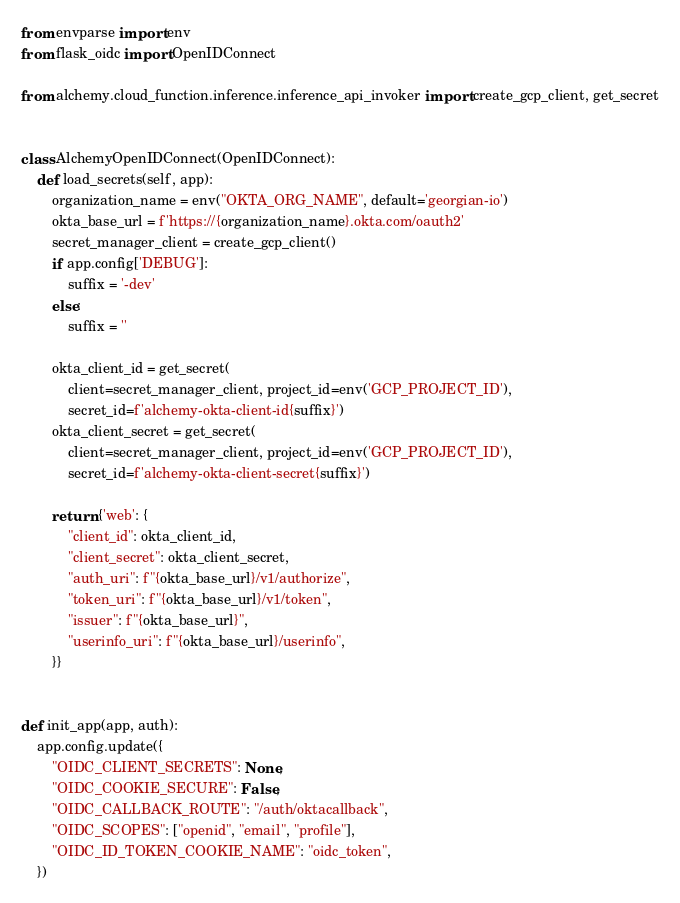Convert code to text. <code><loc_0><loc_0><loc_500><loc_500><_Python_>from envparse import env
from flask_oidc import OpenIDConnect

from alchemy.cloud_function.inference.inference_api_invoker import create_gcp_client, get_secret


class AlchemyOpenIDConnect(OpenIDConnect):
    def load_secrets(self, app):
        organization_name = env("OKTA_ORG_NAME", default='georgian-io')
        okta_base_url = f'https://{organization_name}.okta.com/oauth2'
        secret_manager_client = create_gcp_client()
        if app.config['DEBUG']:
            suffix = '-dev'
        else:
            suffix = ''

        okta_client_id = get_secret(
            client=secret_manager_client, project_id=env('GCP_PROJECT_ID'),
            secret_id=f'alchemy-okta-client-id{suffix}')
        okta_client_secret = get_secret(
            client=secret_manager_client, project_id=env('GCP_PROJECT_ID'),
            secret_id=f'alchemy-okta-client-secret{suffix}')

        return {'web': {
            "client_id": okta_client_id,
            "client_secret": okta_client_secret,
            "auth_uri": f"{okta_base_url}/v1/authorize",
            "token_uri": f"{okta_base_url}/v1/token",
            "issuer": f"{okta_base_url}",
            "userinfo_uri": f"{okta_base_url}/userinfo",
        }}


def init_app(app, auth):
    app.config.update({
        "OIDC_CLIENT_SECRETS": None,
        "OIDC_COOKIE_SECURE": False,
        "OIDC_CALLBACK_ROUTE": "/auth/oktacallback",
        "OIDC_SCOPES": ["openid", "email", "profile"],
        "OIDC_ID_TOKEN_COOKIE_NAME": "oidc_token",
    })
</code> 